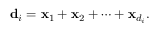<formula> <loc_0><loc_0><loc_500><loc_500>{ d } _ { i } = { x } _ { 1 } + { x } _ { 2 } + \cdots + { x } _ { d _ { i } } .</formula> 